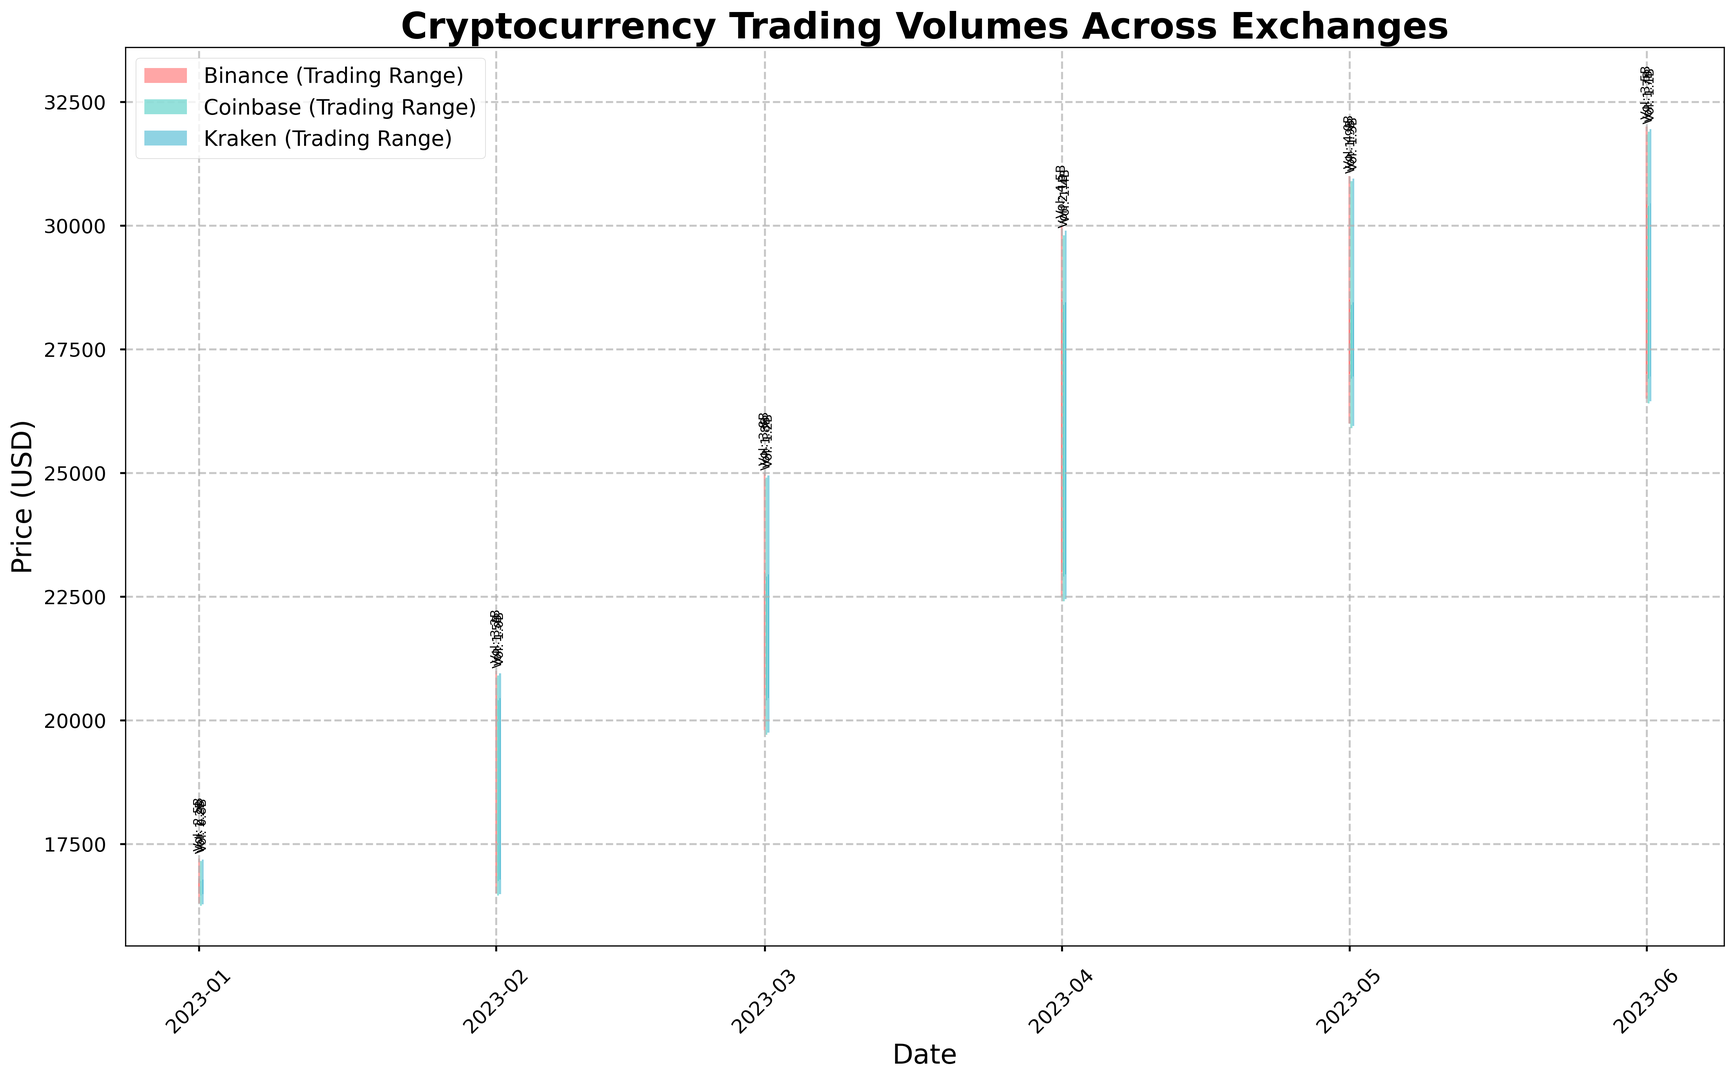How does the trading volume on Binance in April compare to that in May? The trading volume on Binance in April is 4.5 billion, whereas in May it is 4 billion.
Answer: April's volume is higher Which exchange had the highest closing price in February? The closing prices in February are 20500 for Binance, 20400 for Coinbase, and 20450 for Kraken.
Answer: Binance What is the difference in the highest price between March and April for Coinbase? The highest price for Coinbase in March is 24900, and in April it is 29800, so the difference is 29800 - 24900.
Answer: 4900 Which exchange showed the least volatility in June, based on the range between high and low prices? The ranges in June are 32000-26500=5500 for Binance, 31900-26400=5500 for Coinbase, and 31950-26450=5500 for Kraken. All exchanges show the same volatility.
Answer: All same By how much did the closing price on Kraken increase from January to February? Kraken's closing price in January is 16780 and in February is 20450, so the increase is 20450 - 16780.
Answer: 3670 In which month did Binance exhibit the highest absolute price change from open to close? The absolute price changes for Binance are: Jan (16800-16500=300), Feb (20500-16800=3700), Mar (23000-20500=2500), Apr (28500-23000=5500), and May (27000-28500=-1500), Jun (30500-27000=3500), and the highest is in April.
Answer: April Comparing the highs of all exchanges, which exchange reached the highest point and in which month? Binance in April reached the highest point of 30000.
Answer: Binance, April What’s the average closing price for Coinbase from January to June? Summing the closing prices for Coinbase: 16750 + 20400 + 22900 + 28400 + 26900 + 30400 = 145750. Dividing by the number of months (6), 145750 / 6.
Answer: 24291.67 By how much did the volume of trading on Kraken change from March to April? The volume on Kraken in March is 1.2 billion and in April is 1.4 billion, so the change is 1.4 billion - 1.2 billion.
Answer: 0.2 billion Which month showed the lowest closing price for Kraken? The closing prices for Kraken are: Jan (16780), Feb (20450), Mar (22950), Apr (28450), May (26950), Jun (30450), and the lowest is in January.
Answer: January 